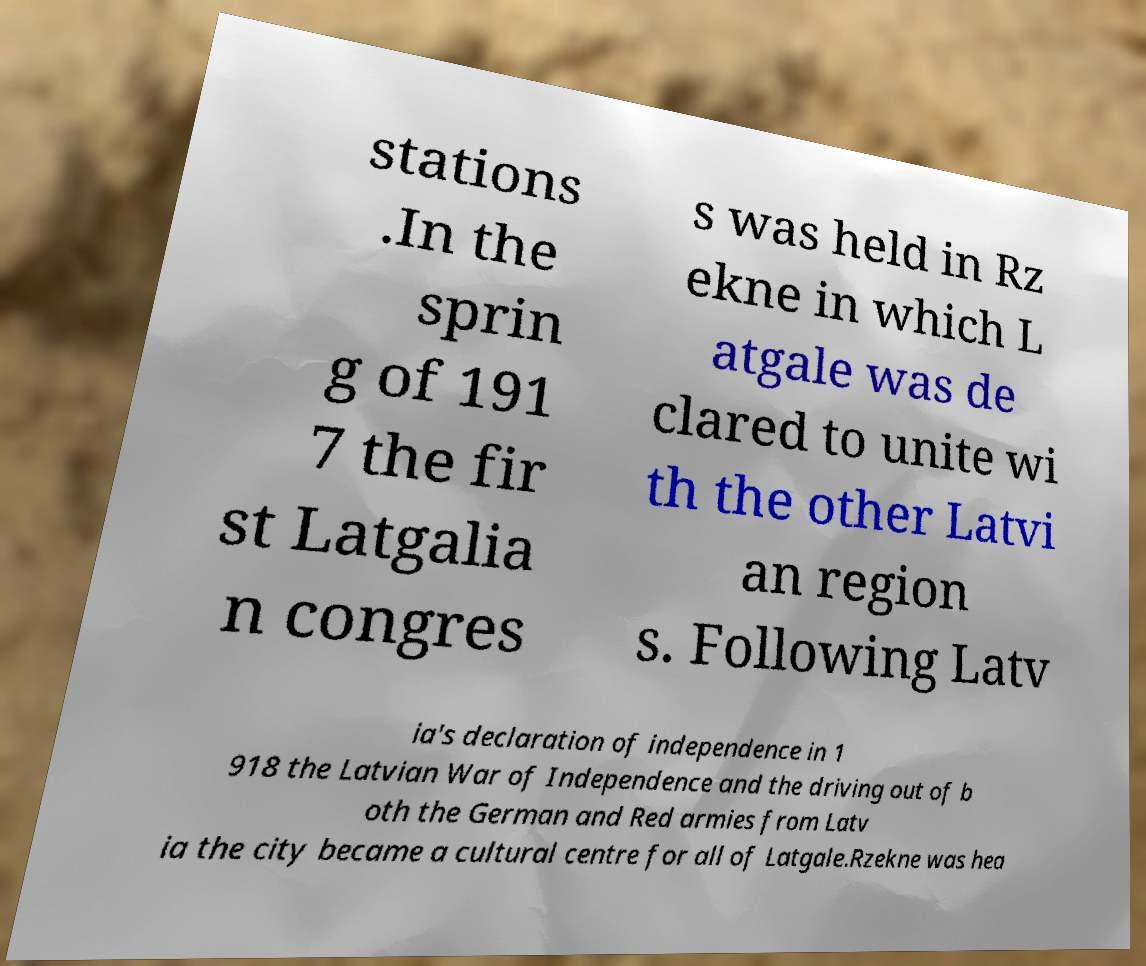What messages or text are displayed in this image? I need them in a readable, typed format. stations .In the sprin g of 191 7 the fir st Latgalia n congres s was held in Rz ekne in which L atgale was de clared to unite wi th the other Latvi an region s. Following Latv ia's declaration of independence in 1 918 the Latvian War of Independence and the driving out of b oth the German and Red armies from Latv ia the city became a cultural centre for all of Latgale.Rzekne was hea 